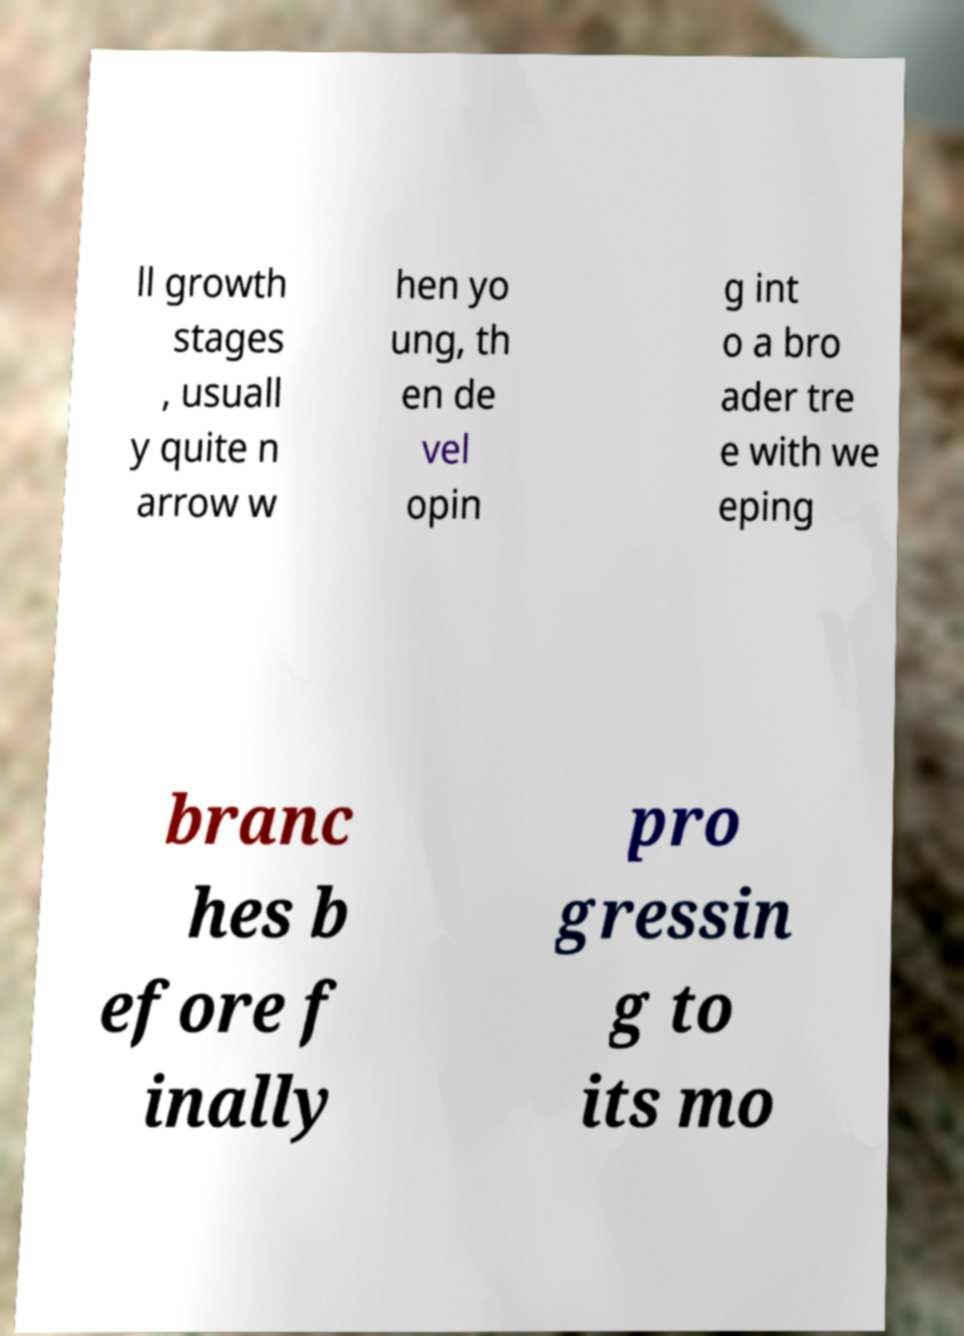Could you extract and type out the text from this image? ll growth stages , usuall y quite n arrow w hen yo ung, th en de vel opin g int o a bro ader tre e with we eping branc hes b efore f inally pro gressin g to its mo 